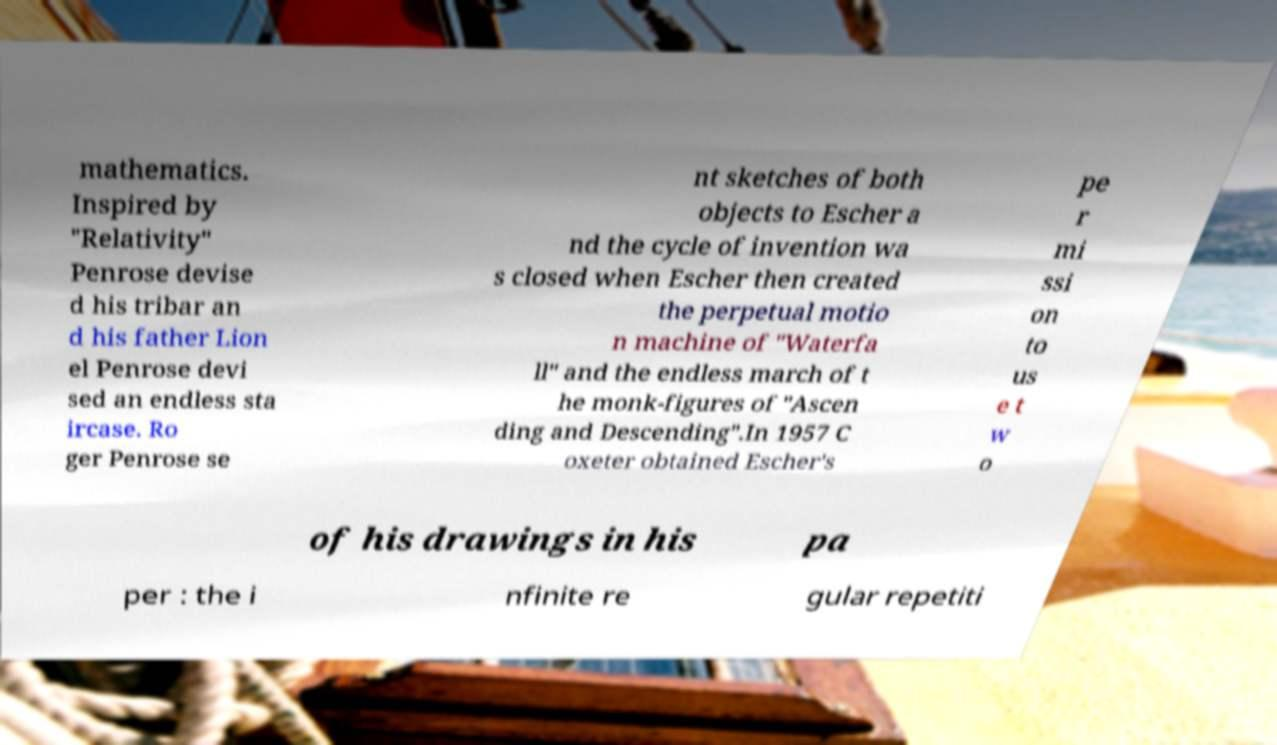Could you assist in decoding the text presented in this image and type it out clearly? mathematics. Inspired by "Relativity" Penrose devise d his tribar an d his father Lion el Penrose devi sed an endless sta ircase. Ro ger Penrose se nt sketches of both objects to Escher a nd the cycle of invention wa s closed when Escher then created the perpetual motio n machine of "Waterfa ll" and the endless march of t he monk-figures of "Ascen ding and Descending".In 1957 C oxeter obtained Escher's pe r mi ssi on to us e t w o of his drawings in his pa per : the i nfinite re gular repetiti 